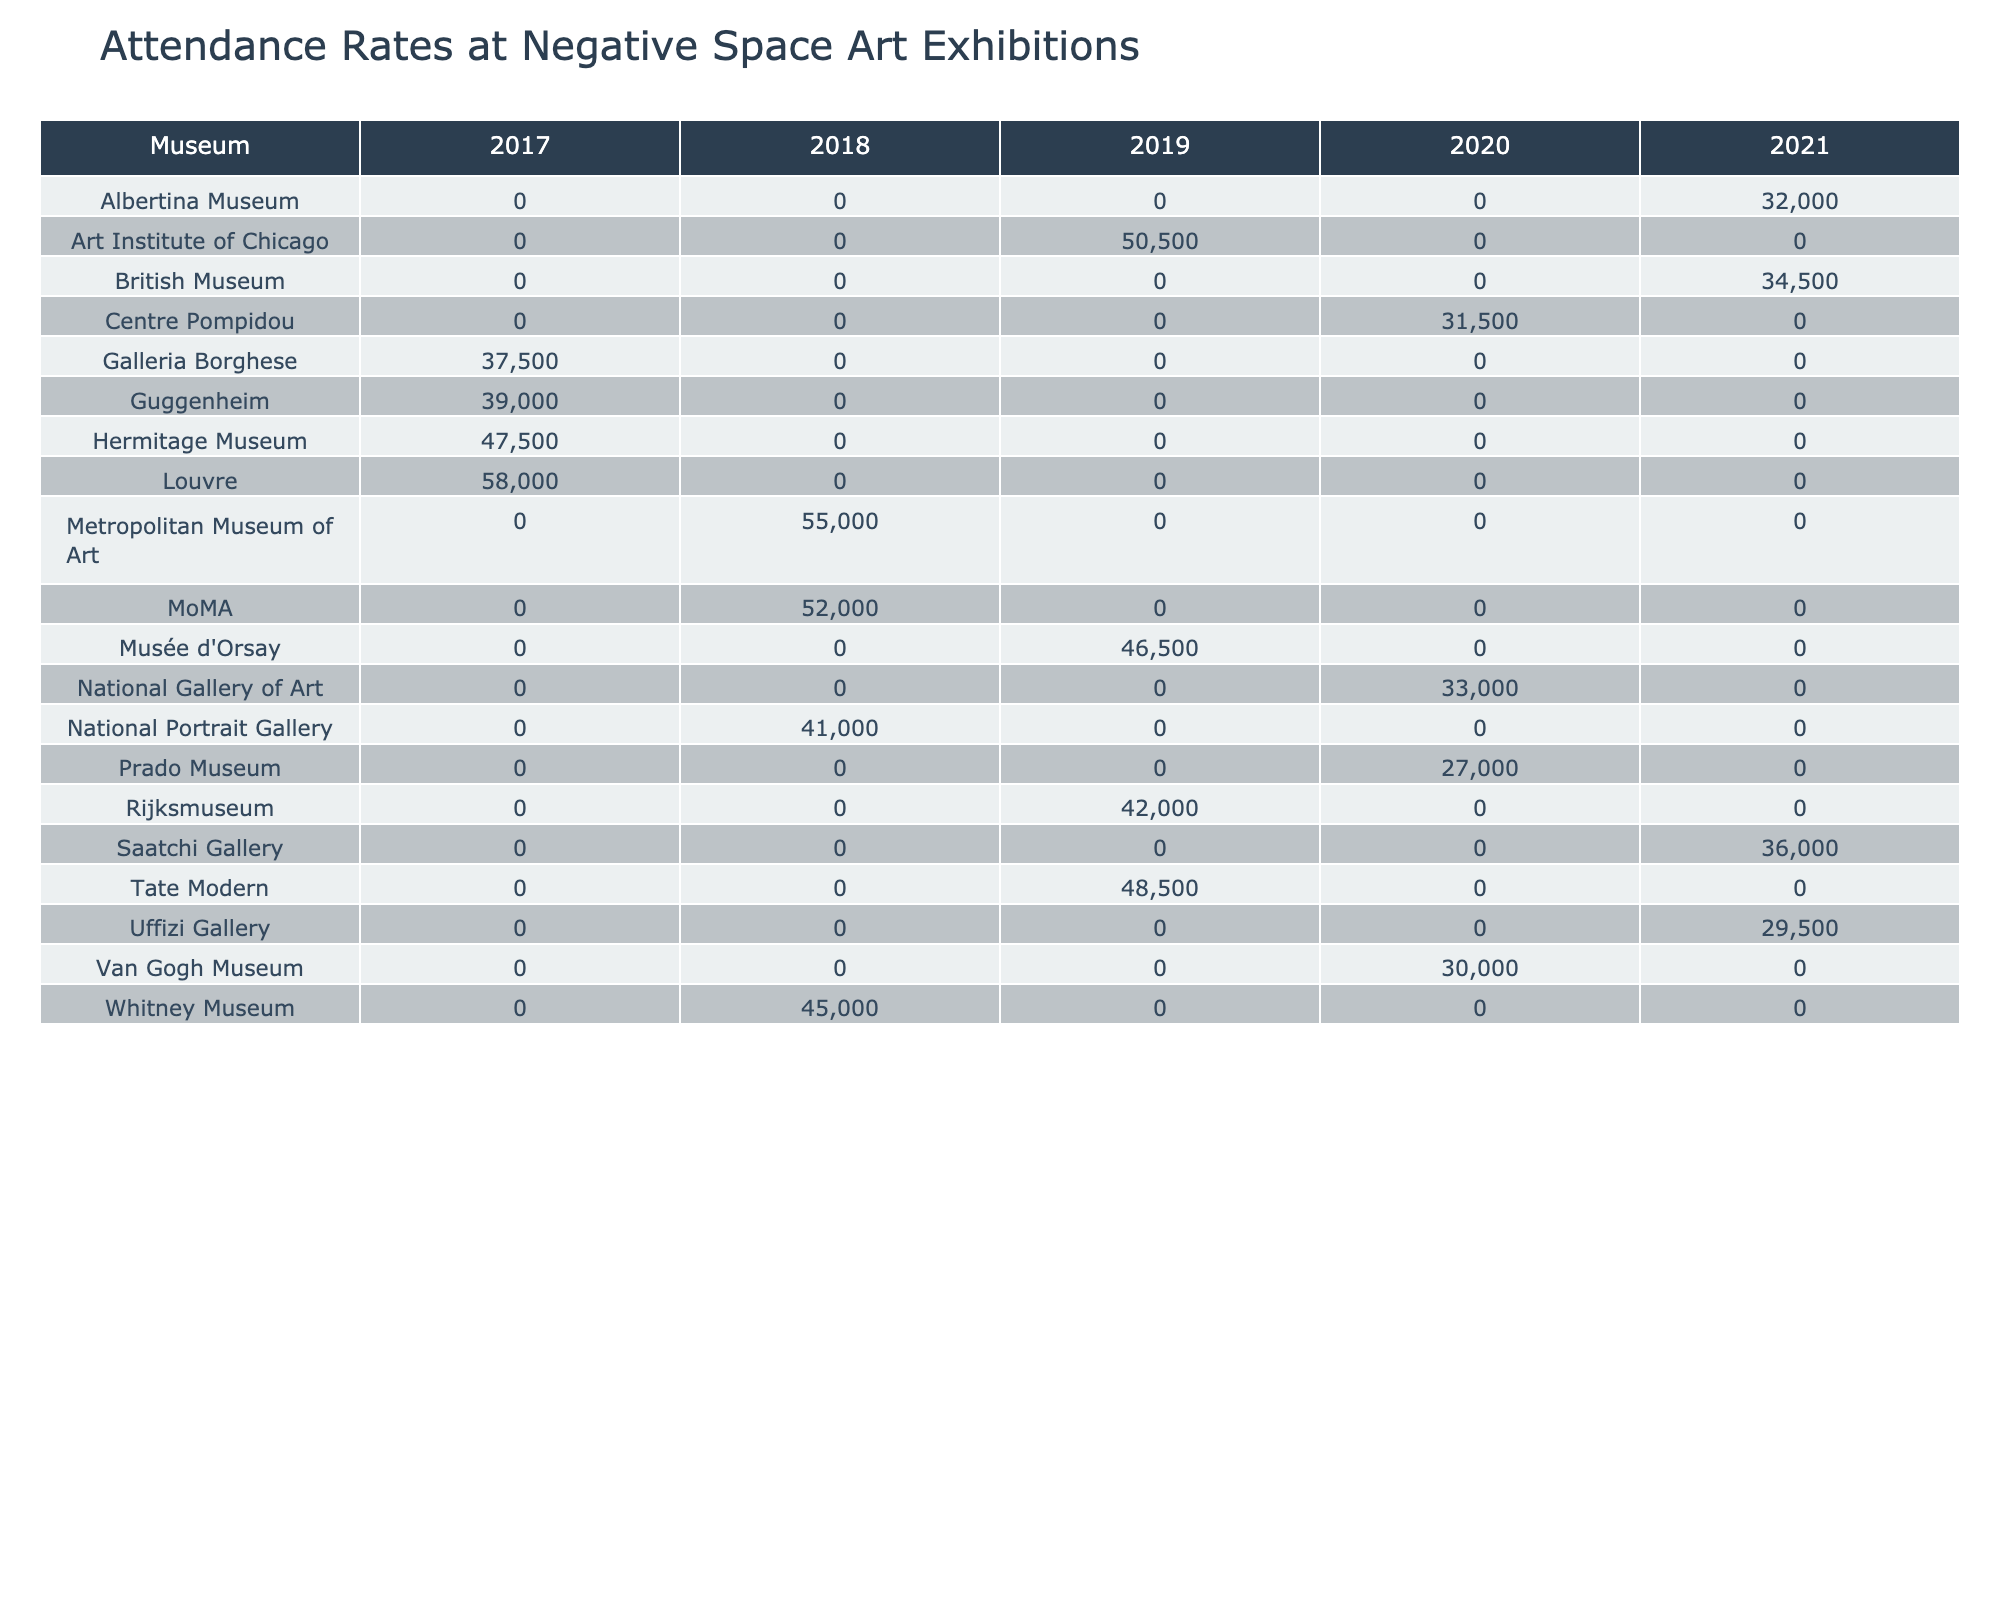What is the highest attendance recorded in 2018? According to the table, the highest attendance in 2018 is from the Metropolitan Museum of Art with 55,000 visitors.
Answer: 55,000 Which museum had the lowest attendance in 2021? The Uffizi Gallery had the lowest attendance in 2021 with 29,500 visitors.
Answer: 29,500 What is the average attendance across all museums in 2019? Adding the attendances for 2019 (48,500 + 50,500 + 42,000 + 46,500) gives a total of 187,500. There are 5 museums in 2019, so the average is 187,500 / 5 = 37,500.
Answer: 37,500 Did any museum see an increase in attendance from 2018 to 2019? Yes, the Art Institute of Chicago had an increase from 50,500 in 2019 compared to 45,000 in 2018.
Answer: Yes Which museum had the highest recorded attendance in 2017? The Louvre had the highest attendance in 2017 with 58,000 visitors.
Answer: 58,000 What is the difference in attendance between the highest and lowest recorded figures in 2020? The highest attendance in 2020 is 33,000 from the National Gallery of Art, and the lowest is 27,000 from the Prado Museum. The difference is 33,000 - 27,000 = 6,000.
Answer: 6,000 Is the attendance at the National Portrait Gallery higher than that at the British Museum in 2021? No, the National Portrait Gallery had 41,000 visitors while the British Museum had 34,500 visitors in 2021.
Answer: No How does attendance in 2019 compare to attendance in 2020 for the same museums? The total attendance for 2019 is (48,500 + 50,500 + 42,000 + 46,500) while for 2020 it is (33,000 + 27,000 + 30,000). This indicates a general decline.
Answer: Decline Which museum shows a pattern of consistently increasing attendance across the years represented? There is no museum that consistently increased attendance; some years show fluctuations.
Answer: No What was the total attendance for all museums in 2018? Adding the attendance figures for all museums in 2018 gives a total of 50,000 + 45,000 + 55,000 + 41,000 = 191,000.
Answer: 191,000 